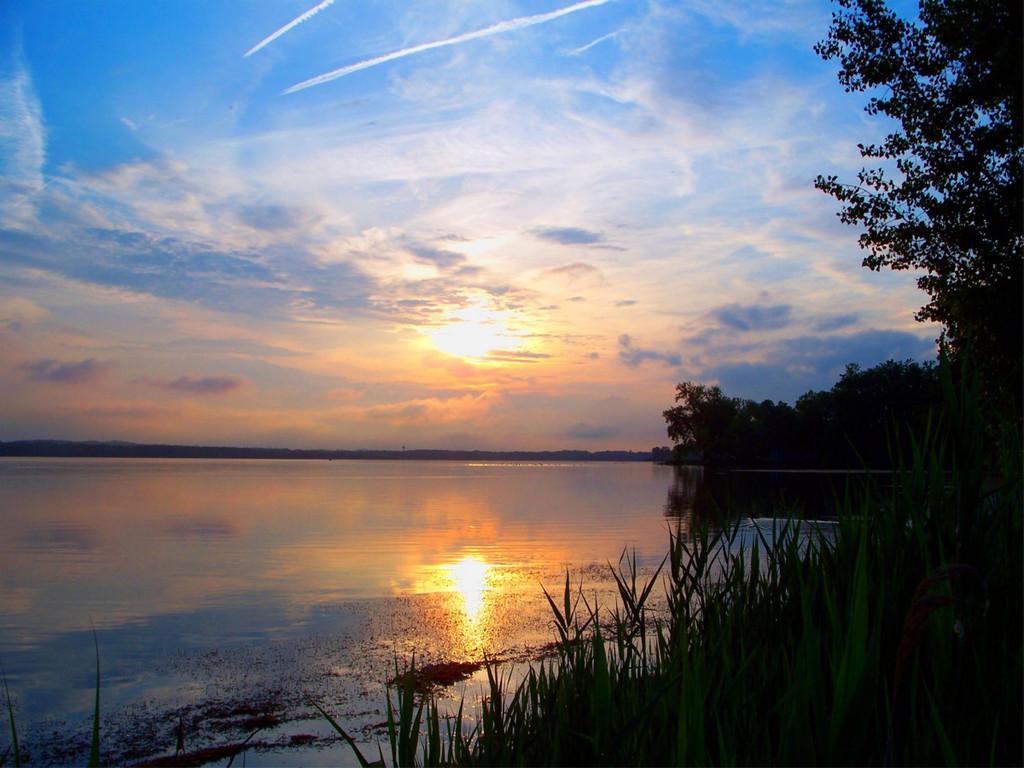In one or two sentences, can you explain what this image depicts? In this image there is a river, in the background there is the sky and sun, in the right side there are trees and plants. 